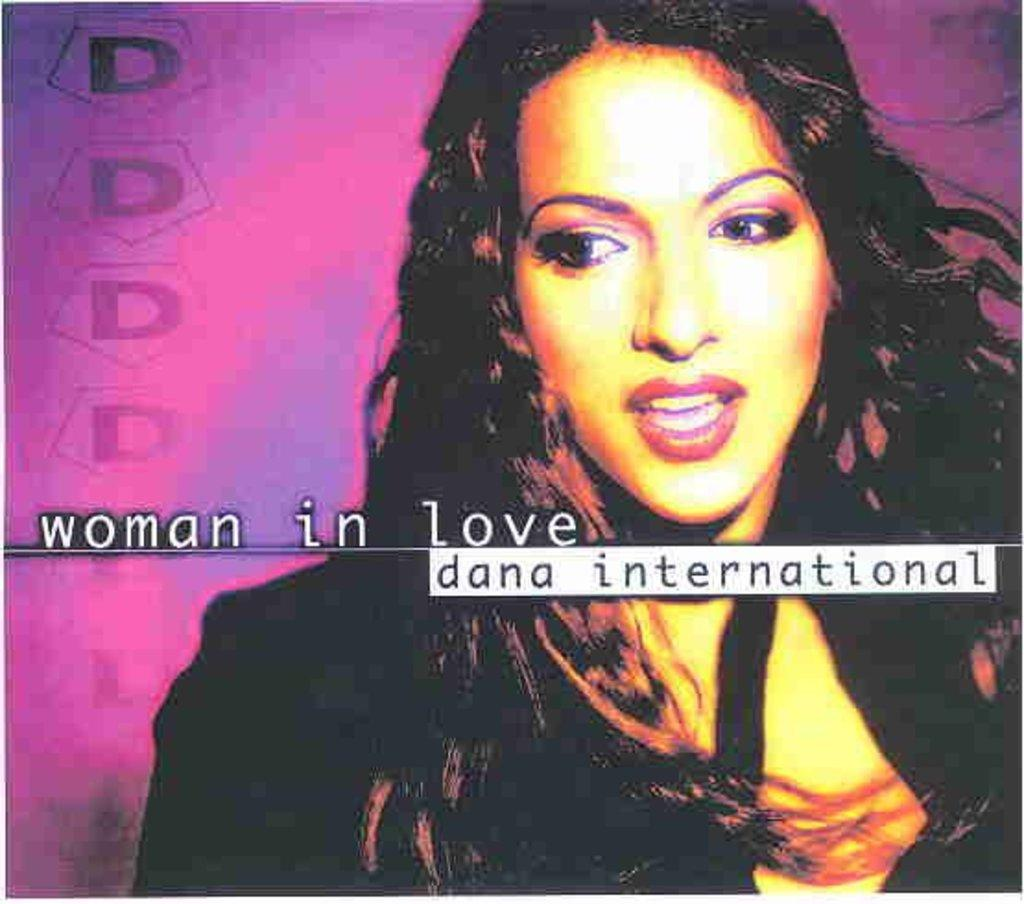What type of image is being described? The image is an edited picture. Who or what is featured in the edited picture? There is a woman in the edited picture. Are there any additional elements in the edited picture besides the woman? Yes, there is text present in the edited picture. What type of punishment is being depicted in the edited picture? There is no punishment being depicted in the edited picture; it features a woman and text. Can you tell me how many plants are visible in the edited picture? There are no plants visible in the edited picture. 